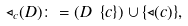Convert formula to latex. <formula><loc_0><loc_0><loc_500><loc_500>\triangleleft _ { c } ( D ) \colon = ( D \ \{ c \} ) \cup \{ \triangleleft ( c ) \} ,</formula> 